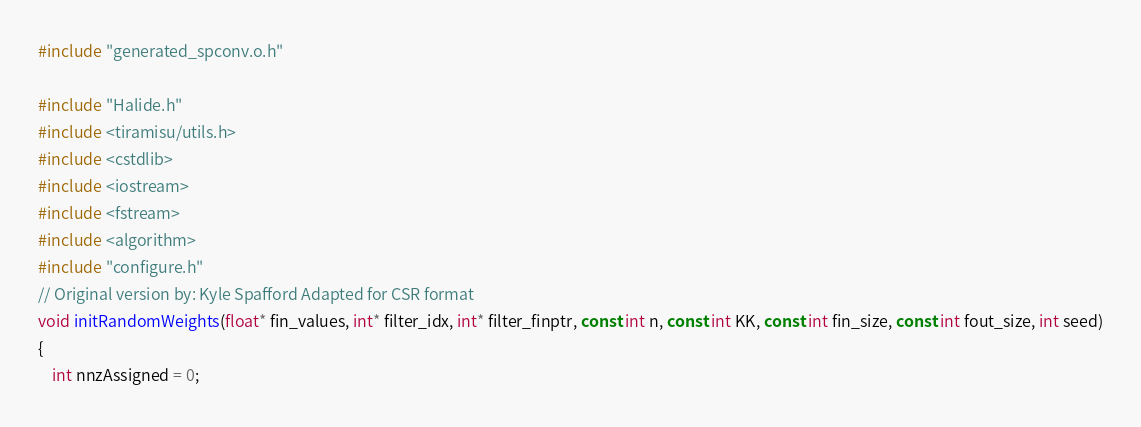Convert code to text. <code><loc_0><loc_0><loc_500><loc_500><_C++_>#include "generated_spconv.o.h"

#include "Halide.h"
#include <tiramisu/utils.h>
#include <cstdlib>
#include <iostream>
#include <fstream>
#include <algorithm>
#include "configure.h"
// Original version by: Kyle Spafford Adapted for CSR format
void initRandomWeights(float* fin_values, int* filter_idx, int* filter_finptr, const int n, const int KK, const int fin_size, const int fout_size, int seed)
{
    int nnzAssigned = 0;</code> 